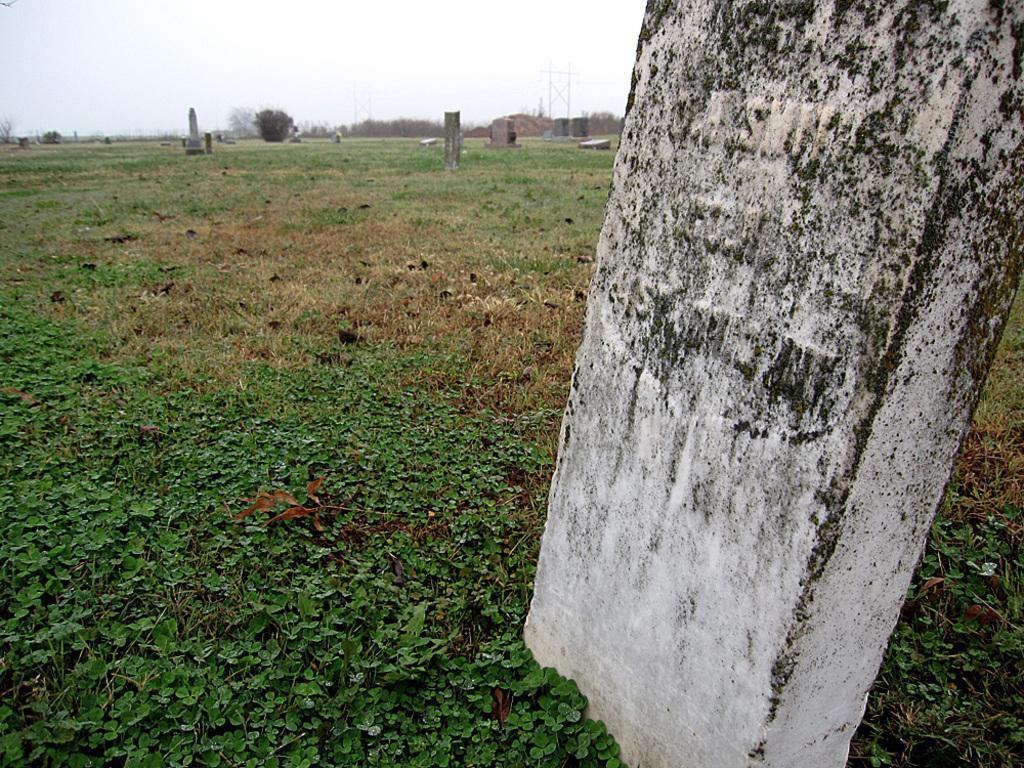Could you give a brief overview of what you see in this image? In this there are few stones in the grass, a few trees and plants, some poles and the sky. 